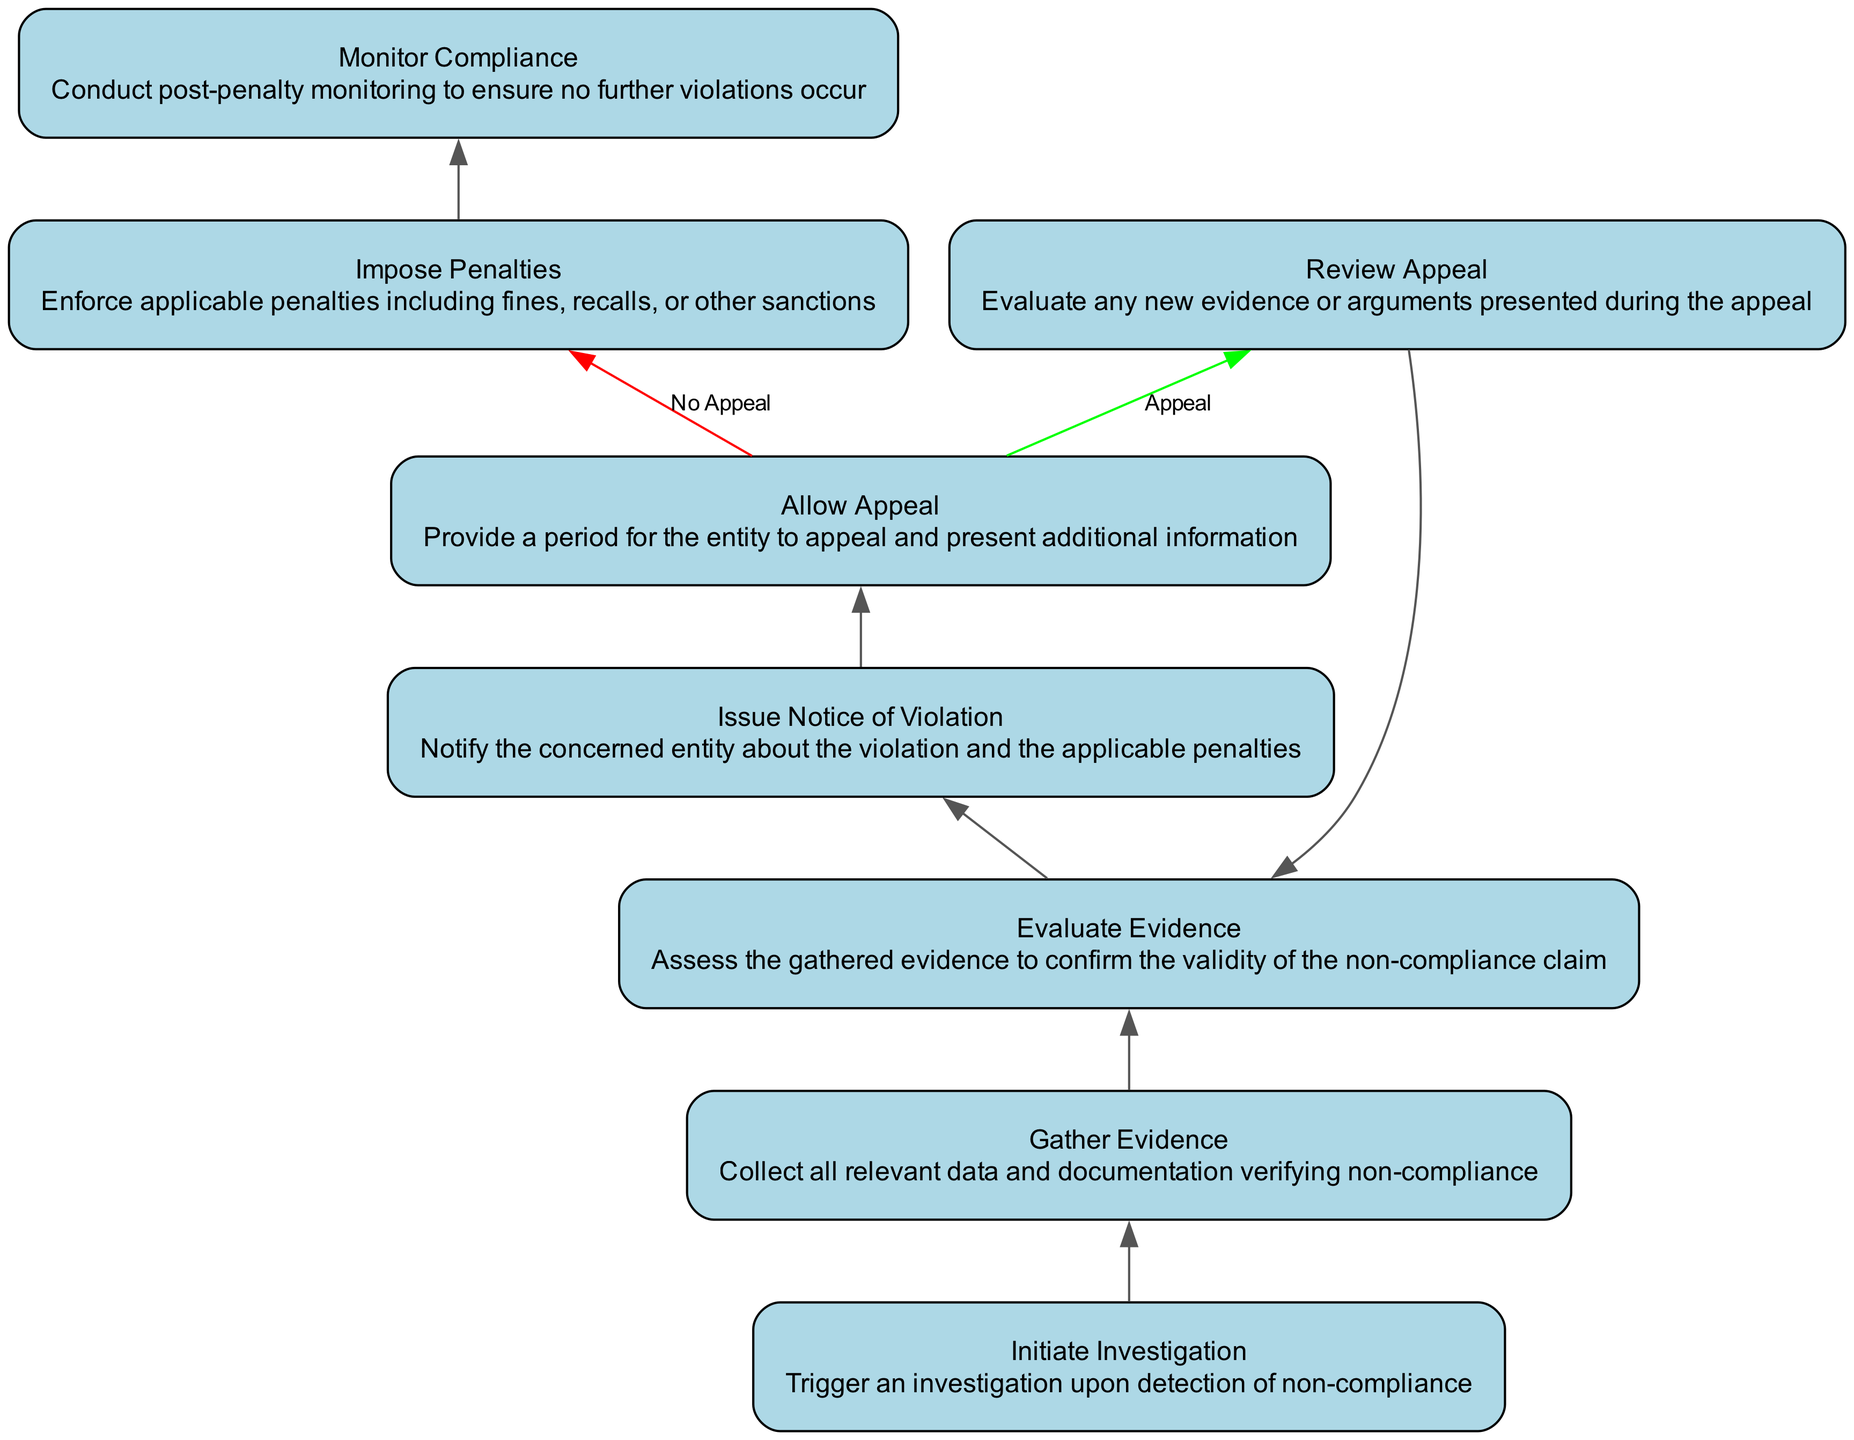What is the first step in the process? The first element in the flowchart is "Initiate Investigation," which describes the action to trigger an investigation upon detection of non-compliance. This is the starting point in the flow of the process.
Answer: Initiate Investigation How many total steps are there in the process? By counting the elements in the diagram, we notice there are a total of 8 steps or nodes, including the final monitoring step.
Answer: 8 What happens after "Allow Appeal"? After the "Allow Appeal" node, there are two possible outcomes: if the appeal is accepted, it leads to "Review Appeal," or if there is no appeal, it proceeds to "Impose Penalties." This structure indicates a decision-making point in the flowchart.
Answer: Review Appeal and Impose Penalties What is the last step of the process? The last step in the flowchart is "Monitor Compliance," which involves conducting post-penalty monitoring to ensure no further violations occur. This is the conclusion of the process.
Answer: Monitor Compliance What does the "Evaluate Evidence" step confirm? The purpose of "Evaluate Evidence" is to assess the gathered evidence to confirm the validity of the non-compliance claim. This step ensures that there is sufficient justification before moving forward in the process.
Answer: Confirm validity of non-compliance claim What are the penalties described in the "Impose Penalties" step? The "Impose Penalties" step indicates that penalties can include fines, recalls, or other sanctions. This outlines the types of consequences that can be applied for non-compliance.
Answer: Fines, recalls, or other sanctions What triggers the "Gather Evidence" step? The "Gather Evidence" step is triggered by the initiation of the investigation, which follows the detection of non-compliance. This indicates a progression in the enforcement process.
Answer: Detection of non-compliance How is the decision made after the "Allow Appeal"? After the "Allow Appeal" step, the decision is made based on whether the entity appeals or not. If the entity appeals, they present additional information, leading to the "Review Appeal" step. If no appeal is made, it goes to "Impose Penalties."
Answer: Based on appeal existence 